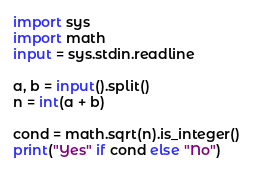Convert code to text. <code><loc_0><loc_0><loc_500><loc_500><_Python_>import sys
import math
input = sys.stdin.readline

a, b = input().split()
n = int(a + b)

cond = math.sqrt(n).is_integer()
print("Yes" if cond else "No")
</code> 